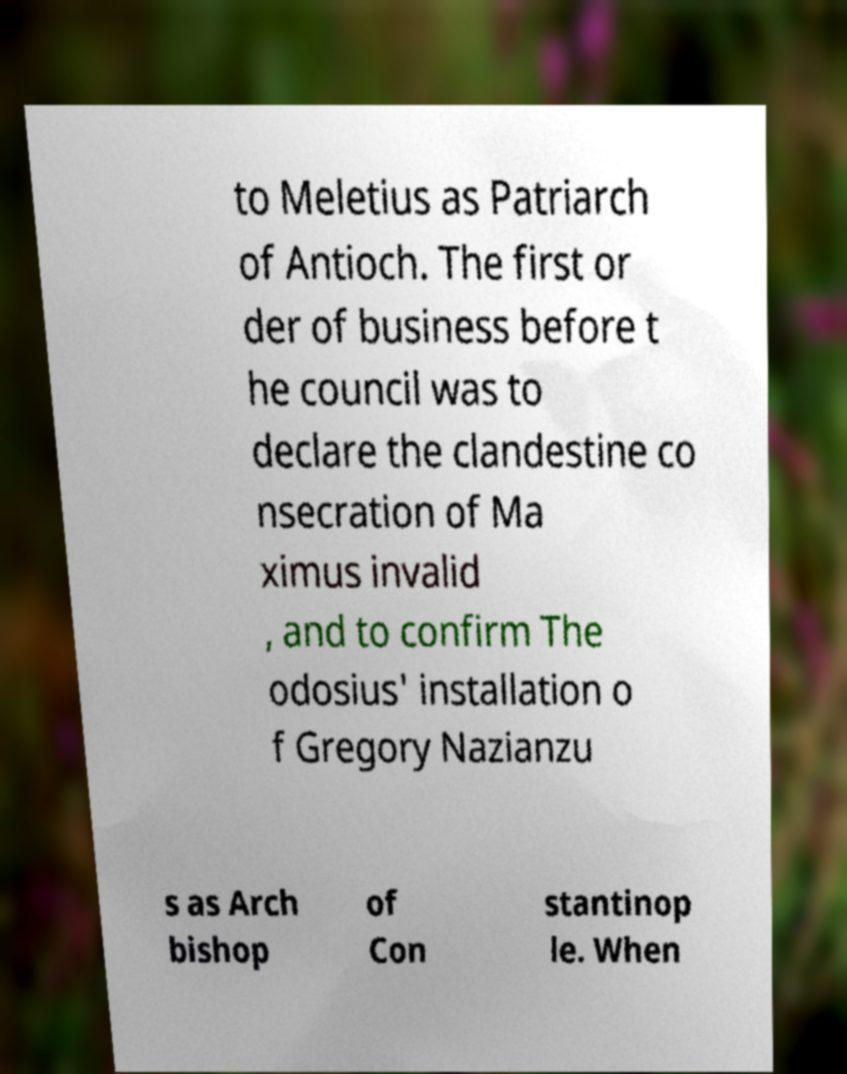For documentation purposes, I need the text within this image transcribed. Could you provide that? to Meletius as Patriarch of Antioch. The first or der of business before t he council was to declare the clandestine co nsecration of Ma ximus invalid , and to confirm The odosius' installation o f Gregory Nazianzu s as Arch bishop of Con stantinop le. When 